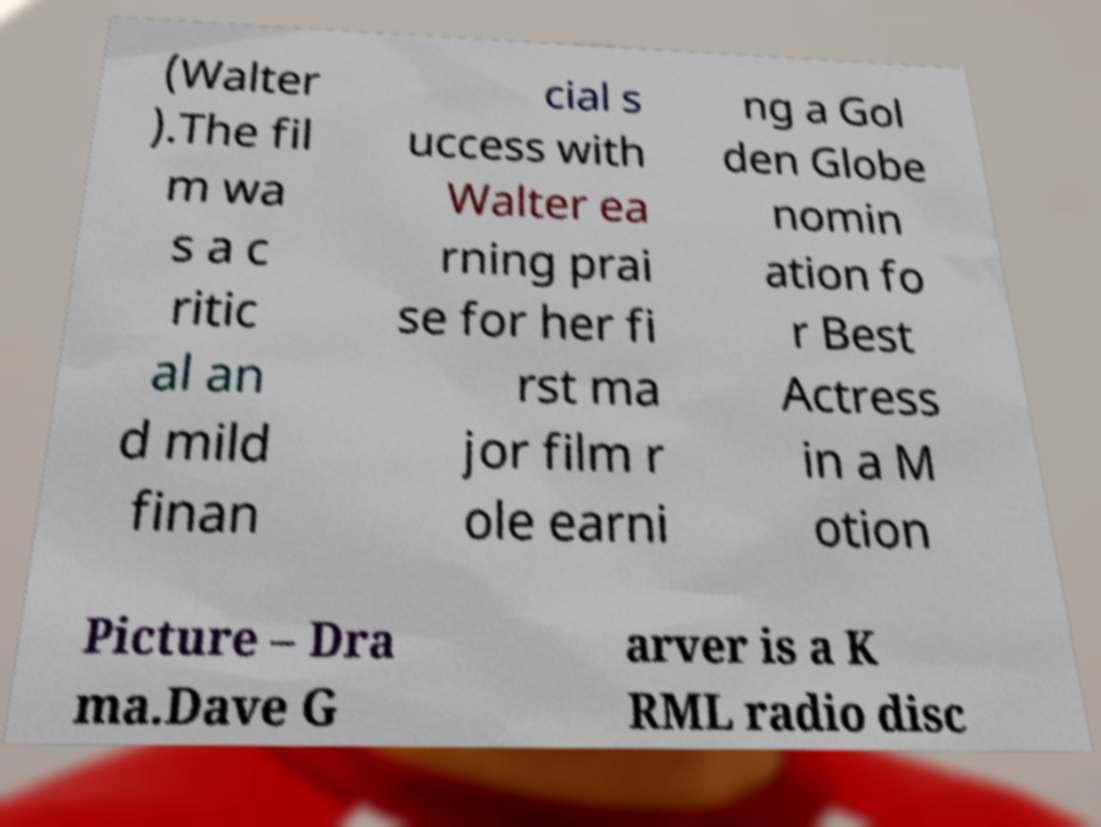Can you accurately transcribe the text from the provided image for me? (Walter ).The fil m wa s a c ritic al an d mild finan cial s uccess with Walter ea rning prai se for her fi rst ma jor film r ole earni ng a Gol den Globe nomin ation fo r Best Actress in a M otion Picture – Dra ma.Dave G arver is a K RML radio disc 